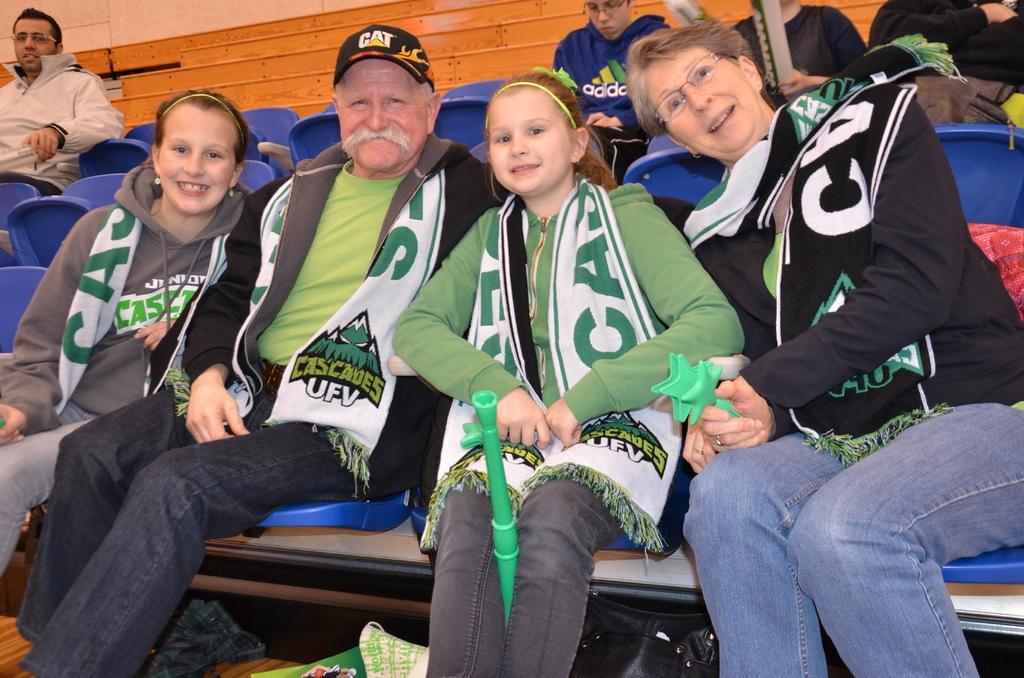In one or two sentences, can you explain what this image depicts? In this image we can see the person sitting on the chairs. In the background there are stairs. 